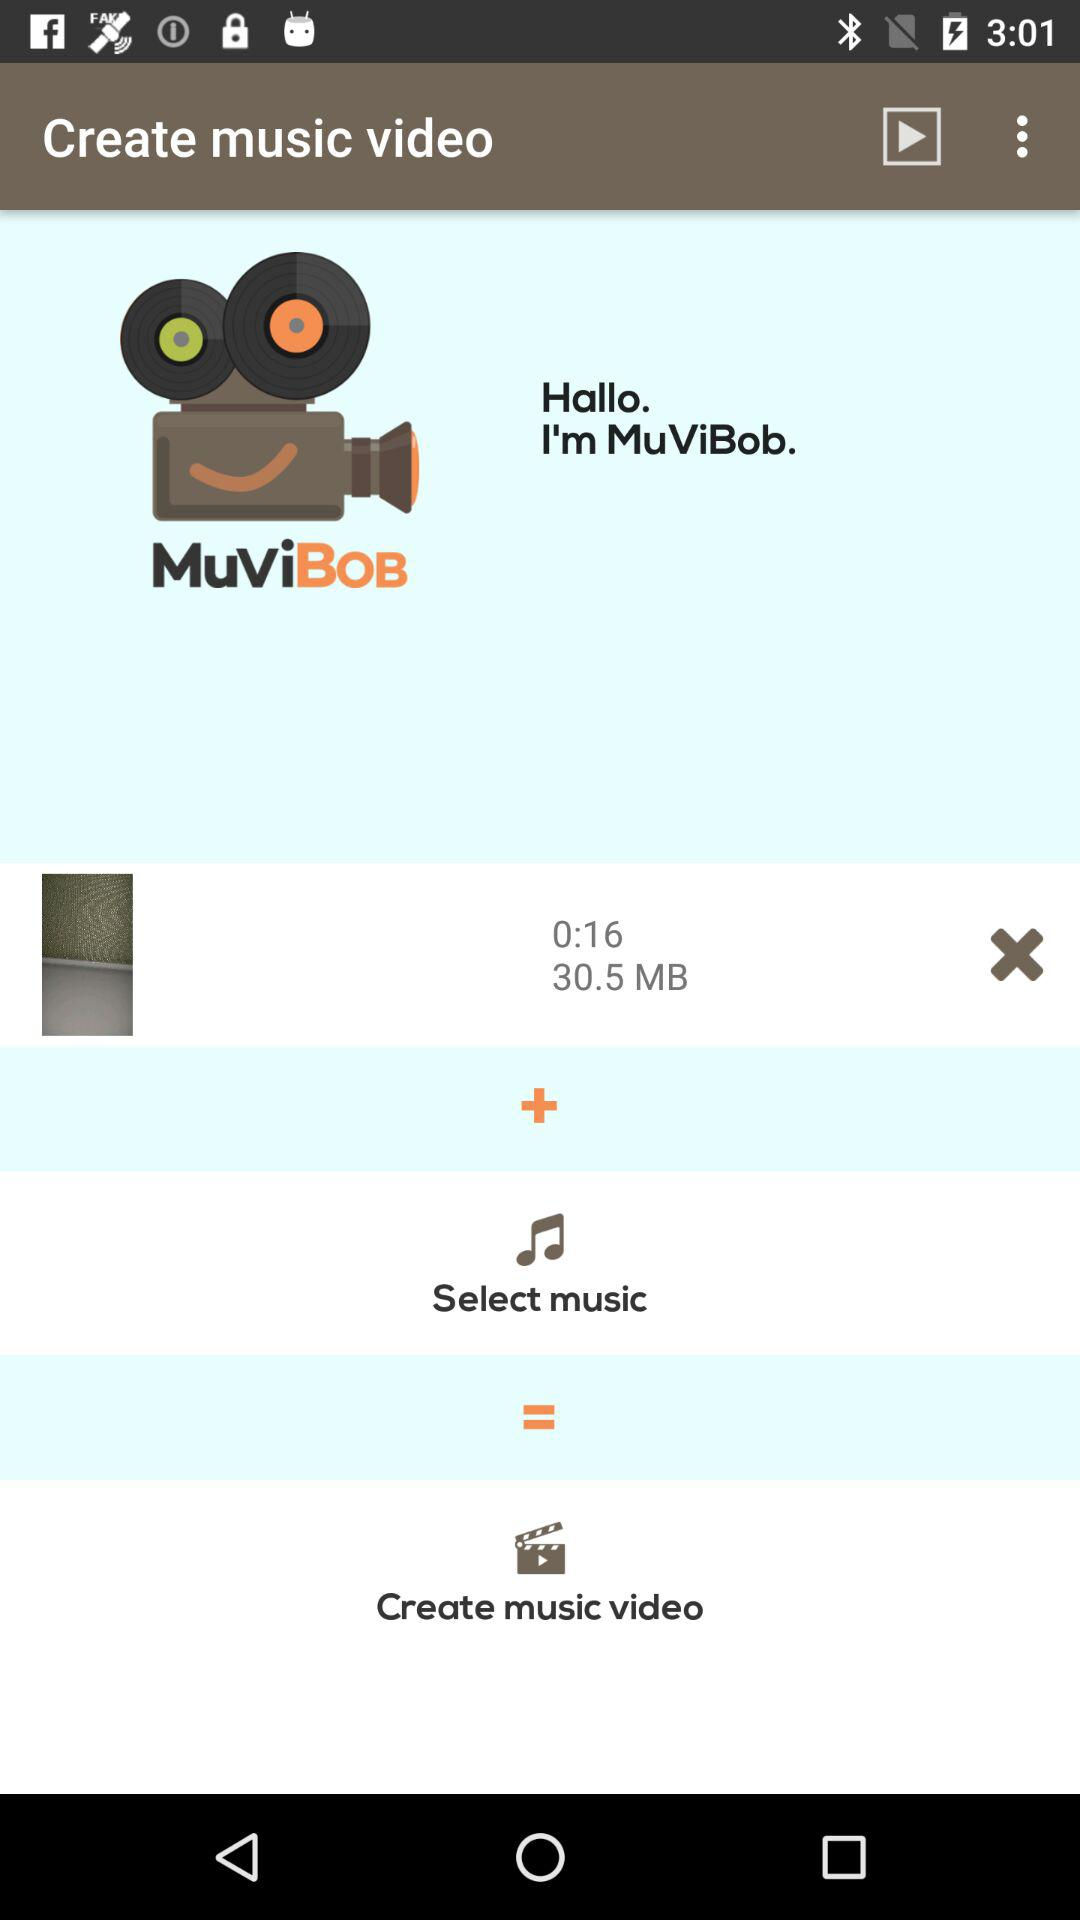How long is the video?
Answer the question using a single word or phrase. 0:16 